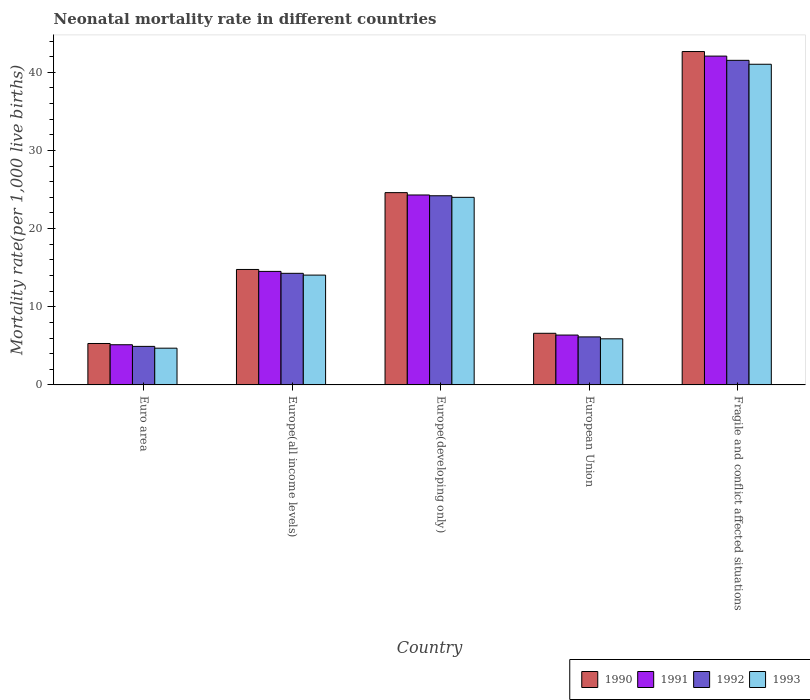How many groups of bars are there?
Keep it short and to the point. 5. Are the number of bars per tick equal to the number of legend labels?
Offer a very short reply. Yes. Are the number of bars on each tick of the X-axis equal?
Provide a short and direct response. Yes. How many bars are there on the 2nd tick from the right?
Your answer should be compact. 4. What is the label of the 5th group of bars from the left?
Ensure brevity in your answer.  Fragile and conflict affected situations. In how many cases, is the number of bars for a given country not equal to the number of legend labels?
Ensure brevity in your answer.  0. What is the neonatal mortality rate in 1993 in Europe(developing only)?
Make the answer very short. 24. Across all countries, what is the maximum neonatal mortality rate in 1990?
Your response must be concise. 42.65. Across all countries, what is the minimum neonatal mortality rate in 1990?
Your response must be concise. 5.3. In which country was the neonatal mortality rate in 1993 maximum?
Your response must be concise. Fragile and conflict affected situations. In which country was the neonatal mortality rate in 1992 minimum?
Ensure brevity in your answer.  Euro area. What is the total neonatal mortality rate in 1992 in the graph?
Keep it short and to the point. 91.07. What is the difference between the neonatal mortality rate in 1992 in European Union and that in Fragile and conflict affected situations?
Provide a succinct answer. -35.38. What is the difference between the neonatal mortality rate in 1991 in Fragile and conflict affected situations and the neonatal mortality rate in 1990 in European Union?
Provide a short and direct response. 35.46. What is the average neonatal mortality rate in 1993 per country?
Make the answer very short. 17.93. What is the difference between the neonatal mortality rate of/in 1992 and neonatal mortality rate of/in 1993 in Europe(all income levels)?
Your answer should be very brief. 0.23. What is the ratio of the neonatal mortality rate in 1990 in Europe(all income levels) to that in European Union?
Offer a very short reply. 2.24. Is the neonatal mortality rate in 1990 in Europe(all income levels) less than that in Fragile and conflict affected situations?
Your answer should be compact. Yes. What is the difference between the highest and the second highest neonatal mortality rate in 1993?
Offer a very short reply. -17.03. What is the difference between the highest and the lowest neonatal mortality rate in 1991?
Give a very brief answer. 36.93. Is the sum of the neonatal mortality rate in 1993 in Euro area and Europe(all income levels) greater than the maximum neonatal mortality rate in 1992 across all countries?
Your answer should be very brief. No. Is it the case that in every country, the sum of the neonatal mortality rate in 1991 and neonatal mortality rate in 1990 is greater than the sum of neonatal mortality rate in 1992 and neonatal mortality rate in 1993?
Offer a terse response. No. What does the 1st bar from the right in Euro area represents?
Your answer should be compact. 1993. Is it the case that in every country, the sum of the neonatal mortality rate in 1991 and neonatal mortality rate in 1992 is greater than the neonatal mortality rate in 1990?
Offer a very short reply. Yes. What is the difference between two consecutive major ticks on the Y-axis?
Ensure brevity in your answer.  10. Does the graph contain grids?
Provide a short and direct response. No. How are the legend labels stacked?
Your answer should be very brief. Horizontal. What is the title of the graph?
Provide a succinct answer. Neonatal mortality rate in different countries. What is the label or title of the X-axis?
Ensure brevity in your answer.  Country. What is the label or title of the Y-axis?
Give a very brief answer. Mortality rate(per 1,0 live births). What is the Mortality rate(per 1,000 live births) of 1990 in Euro area?
Your response must be concise. 5.3. What is the Mortality rate(per 1,000 live births) in 1991 in Euro area?
Offer a very short reply. 5.14. What is the Mortality rate(per 1,000 live births) of 1992 in Euro area?
Keep it short and to the point. 4.93. What is the Mortality rate(per 1,000 live births) of 1993 in Euro area?
Ensure brevity in your answer.  4.7. What is the Mortality rate(per 1,000 live births) in 1990 in Europe(all income levels)?
Give a very brief answer. 14.77. What is the Mortality rate(per 1,000 live births) in 1991 in Europe(all income levels)?
Offer a very short reply. 14.52. What is the Mortality rate(per 1,000 live births) in 1992 in Europe(all income levels)?
Provide a short and direct response. 14.28. What is the Mortality rate(per 1,000 live births) in 1993 in Europe(all income levels)?
Your answer should be very brief. 14.05. What is the Mortality rate(per 1,000 live births) of 1990 in Europe(developing only)?
Your response must be concise. 24.6. What is the Mortality rate(per 1,000 live births) of 1991 in Europe(developing only)?
Provide a short and direct response. 24.3. What is the Mortality rate(per 1,000 live births) of 1992 in Europe(developing only)?
Your answer should be very brief. 24.2. What is the Mortality rate(per 1,000 live births) of 1993 in Europe(developing only)?
Your answer should be very brief. 24. What is the Mortality rate(per 1,000 live births) of 1990 in European Union?
Make the answer very short. 6.6. What is the Mortality rate(per 1,000 live births) of 1991 in European Union?
Keep it short and to the point. 6.38. What is the Mortality rate(per 1,000 live births) in 1992 in European Union?
Make the answer very short. 6.14. What is the Mortality rate(per 1,000 live births) of 1993 in European Union?
Ensure brevity in your answer.  5.9. What is the Mortality rate(per 1,000 live births) in 1990 in Fragile and conflict affected situations?
Ensure brevity in your answer.  42.65. What is the Mortality rate(per 1,000 live births) in 1991 in Fragile and conflict affected situations?
Offer a terse response. 42.07. What is the Mortality rate(per 1,000 live births) in 1992 in Fragile and conflict affected situations?
Your answer should be very brief. 41.53. What is the Mortality rate(per 1,000 live births) of 1993 in Fragile and conflict affected situations?
Ensure brevity in your answer.  41.03. Across all countries, what is the maximum Mortality rate(per 1,000 live births) of 1990?
Your response must be concise. 42.65. Across all countries, what is the maximum Mortality rate(per 1,000 live births) in 1991?
Offer a very short reply. 42.07. Across all countries, what is the maximum Mortality rate(per 1,000 live births) of 1992?
Your answer should be very brief. 41.53. Across all countries, what is the maximum Mortality rate(per 1,000 live births) in 1993?
Provide a succinct answer. 41.03. Across all countries, what is the minimum Mortality rate(per 1,000 live births) of 1990?
Ensure brevity in your answer.  5.3. Across all countries, what is the minimum Mortality rate(per 1,000 live births) of 1991?
Keep it short and to the point. 5.14. Across all countries, what is the minimum Mortality rate(per 1,000 live births) of 1992?
Offer a very short reply. 4.93. Across all countries, what is the minimum Mortality rate(per 1,000 live births) of 1993?
Your answer should be very brief. 4.7. What is the total Mortality rate(per 1,000 live births) of 1990 in the graph?
Make the answer very short. 93.93. What is the total Mortality rate(per 1,000 live births) in 1991 in the graph?
Your answer should be very brief. 92.41. What is the total Mortality rate(per 1,000 live births) in 1992 in the graph?
Offer a terse response. 91.07. What is the total Mortality rate(per 1,000 live births) in 1993 in the graph?
Give a very brief answer. 89.67. What is the difference between the Mortality rate(per 1,000 live births) in 1990 in Euro area and that in Europe(all income levels)?
Your response must be concise. -9.47. What is the difference between the Mortality rate(per 1,000 live births) in 1991 in Euro area and that in Europe(all income levels)?
Provide a succinct answer. -9.38. What is the difference between the Mortality rate(per 1,000 live births) in 1992 in Euro area and that in Europe(all income levels)?
Your answer should be very brief. -9.35. What is the difference between the Mortality rate(per 1,000 live births) of 1993 in Euro area and that in Europe(all income levels)?
Your response must be concise. -9.35. What is the difference between the Mortality rate(per 1,000 live births) of 1990 in Euro area and that in Europe(developing only)?
Offer a terse response. -19.3. What is the difference between the Mortality rate(per 1,000 live births) in 1991 in Euro area and that in Europe(developing only)?
Your response must be concise. -19.16. What is the difference between the Mortality rate(per 1,000 live births) of 1992 in Euro area and that in Europe(developing only)?
Give a very brief answer. -19.27. What is the difference between the Mortality rate(per 1,000 live births) of 1993 in Euro area and that in Europe(developing only)?
Your answer should be very brief. -19.3. What is the difference between the Mortality rate(per 1,000 live births) of 1990 in Euro area and that in European Union?
Offer a very short reply. -1.3. What is the difference between the Mortality rate(per 1,000 live births) of 1991 in Euro area and that in European Union?
Your answer should be compact. -1.24. What is the difference between the Mortality rate(per 1,000 live births) of 1992 in Euro area and that in European Union?
Provide a succinct answer. -1.21. What is the difference between the Mortality rate(per 1,000 live births) of 1993 in Euro area and that in European Union?
Provide a short and direct response. -1.2. What is the difference between the Mortality rate(per 1,000 live births) of 1990 in Euro area and that in Fragile and conflict affected situations?
Your answer should be very brief. -37.35. What is the difference between the Mortality rate(per 1,000 live births) of 1991 in Euro area and that in Fragile and conflict affected situations?
Provide a succinct answer. -36.93. What is the difference between the Mortality rate(per 1,000 live births) in 1992 in Euro area and that in Fragile and conflict affected situations?
Provide a short and direct response. -36.6. What is the difference between the Mortality rate(per 1,000 live births) in 1993 in Euro area and that in Fragile and conflict affected situations?
Keep it short and to the point. -36.33. What is the difference between the Mortality rate(per 1,000 live births) of 1990 in Europe(all income levels) and that in Europe(developing only)?
Your answer should be very brief. -9.83. What is the difference between the Mortality rate(per 1,000 live births) in 1991 in Europe(all income levels) and that in Europe(developing only)?
Ensure brevity in your answer.  -9.78. What is the difference between the Mortality rate(per 1,000 live births) of 1992 in Europe(all income levels) and that in Europe(developing only)?
Offer a very short reply. -9.92. What is the difference between the Mortality rate(per 1,000 live births) of 1993 in Europe(all income levels) and that in Europe(developing only)?
Make the answer very short. -9.95. What is the difference between the Mortality rate(per 1,000 live births) in 1990 in Europe(all income levels) and that in European Union?
Ensure brevity in your answer.  8.17. What is the difference between the Mortality rate(per 1,000 live births) of 1991 in Europe(all income levels) and that in European Union?
Provide a succinct answer. 8.14. What is the difference between the Mortality rate(per 1,000 live births) of 1992 in Europe(all income levels) and that in European Union?
Provide a succinct answer. 8.14. What is the difference between the Mortality rate(per 1,000 live births) in 1993 in Europe(all income levels) and that in European Union?
Make the answer very short. 8.15. What is the difference between the Mortality rate(per 1,000 live births) in 1990 in Europe(all income levels) and that in Fragile and conflict affected situations?
Keep it short and to the point. -27.88. What is the difference between the Mortality rate(per 1,000 live births) of 1991 in Europe(all income levels) and that in Fragile and conflict affected situations?
Give a very brief answer. -27.55. What is the difference between the Mortality rate(per 1,000 live births) in 1992 in Europe(all income levels) and that in Fragile and conflict affected situations?
Your answer should be very brief. -27.25. What is the difference between the Mortality rate(per 1,000 live births) of 1993 in Europe(all income levels) and that in Fragile and conflict affected situations?
Make the answer very short. -26.98. What is the difference between the Mortality rate(per 1,000 live births) in 1990 in Europe(developing only) and that in European Union?
Make the answer very short. 18. What is the difference between the Mortality rate(per 1,000 live births) of 1991 in Europe(developing only) and that in European Union?
Offer a terse response. 17.92. What is the difference between the Mortality rate(per 1,000 live births) in 1992 in Europe(developing only) and that in European Union?
Provide a short and direct response. 18.06. What is the difference between the Mortality rate(per 1,000 live births) in 1993 in Europe(developing only) and that in European Union?
Your response must be concise. 18.1. What is the difference between the Mortality rate(per 1,000 live births) of 1990 in Europe(developing only) and that in Fragile and conflict affected situations?
Your response must be concise. -18.05. What is the difference between the Mortality rate(per 1,000 live births) in 1991 in Europe(developing only) and that in Fragile and conflict affected situations?
Ensure brevity in your answer.  -17.77. What is the difference between the Mortality rate(per 1,000 live births) of 1992 in Europe(developing only) and that in Fragile and conflict affected situations?
Offer a terse response. -17.33. What is the difference between the Mortality rate(per 1,000 live births) of 1993 in Europe(developing only) and that in Fragile and conflict affected situations?
Provide a short and direct response. -17.03. What is the difference between the Mortality rate(per 1,000 live births) in 1990 in European Union and that in Fragile and conflict affected situations?
Your response must be concise. -36.05. What is the difference between the Mortality rate(per 1,000 live births) of 1991 in European Union and that in Fragile and conflict affected situations?
Keep it short and to the point. -35.69. What is the difference between the Mortality rate(per 1,000 live births) in 1992 in European Union and that in Fragile and conflict affected situations?
Your answer should be compact. -35.38. What is the difference between the Mortality rate(per 1,000 live births) of 1993 in European Union and that in Fragile and conflict affected situations?
Ensure brevity in your answer.  -35.13. What is the difference between the Mortality rate(per 1,000 live births) of 1990 in Euro area and the Mortality rate(per 1,000 live births) of 1991 in Europe(all income levels)?
Your answer should be compact. -9.22. What is the difference between the Mortality rate(per 1,000 live births) of 1990 in Euro area and the Mortality rate(per 1,000 live births) of 1992 in Europe(all income levels)?
Your answer should be very brief. -8.98. What is the difference between the Mortality rate(per 1,000 live births) of 1990 in Euro area and the Mortality rate(per 1,000 live births) of 1993 in Europe(all income levels)?
Keep it short and to the point. -8.75. What is the difference between the Mortality rate(per 1,000 live births) in 1991 in Euro area and the Mortality rate(per 1,000 live births) in 1992 in Europe(all income levels)?
Offer a terse response. -9.14. What is the difference between the Mortality rate(per 1,000 live births) of 1991 in Euro area and the Mortality rate(per 1,000 live births) of 1993 in Europe(all income levels)?
Offer a very short reply. -8.91. What is the difference between the Mortality rate(per 1,000 live births) in 1992 in Euro area and the Mortality rate(per 1,000 live births) in 1993 in Europe(all income levels)?
Your answer should be compact. -9.12. What is the difference between the Mortality rate(per 1,000 live births) in 1990 in Euro area and the Mortality rate(per 1,000 live births) in 1991 in Europe(developing only)?
Your answer should be very brief. -19. What is the difference between the Mortality rate(per 1,000 live births) of 1990 in Euro area and the Mortality rate(per 1,000 live births) of 1992 in Europe(developing only)?
Provide a succinct answer. -18.9. What is the difference between the Mortality rate(per 1,000 live births) of 1990 in Euro area and the Mortality rate(per 1,000 live births) of 1993 in Europe(developing only)?
Provide a short and direct response. -18.7. What is the difference between the Mortality rate(per 1,000 live births) of 1991 in Euro area and the Mortality rate(per 1,000 live births) of 1992 in Europe(developing only)?
Provide a short and direct response. -19.06. What is the difference between the Mortality rate(per 1,000 live births) of 1991 in Euro area and the Mortality rate(per 1,000 live births) of 1993 in Europe(developing only)?
Your response must be concise. -18.86. What is the difference between the Mortality rate(per 1,000 live births) in 1992 in Euro area and the Mortality rate(per 1,000 live births) in 1993 in Europe(developing only)?
Keep it short and to the point. -19.07. What is the difference between the Mortality rate(per 1,000 live births) of 1990 in Euro area and the Mortality rate(per 1,000 live births) of 1991 in European Union?
Keep it short and to the point. -1.08. What is the difference between the Mortality rate(per 1,000 live births) of 1990 in Euro area and the Mortality rate(per 1,000 live births) of 1992 in European Union?
Offer a very short reply. -0.84. What is the difference between the Mortality rate(per 1,000 live births) in 1990 in Euro area and the Mortality rate(per 1,000 live births) in 1993 in European Union?
Give a very brief answer. -0.6. What is the difference between the Mortality rate(per 1,000 live births) of 1991 in Euro area and the Mortality rate(per 1,000 live births) of 1992 in European Union?
Make the answer very short. -1. What is the difference between the Mortality rate(per 1,000 live births) of 1991 in Euro area and the Mortality rate(per 1,000 live births) of 1993 in European Union?
Provide a short and direct response. -0.76. What is the difference between the Mortality rate(per 1,000 live births) in 1992 in Euro area and the Mortality rate(per 1,000 live births) in 1993 in European Union?
Offer a terse response. -0.97. What is the difference between the Mortality rate(per 1,000 live births) in 1990 in Euro area and the Mortality rate(per 1,000 live births) in 1991 in Fragile and conflict affected situations?
Provide a short and direct response. -36.77. What is the difference between the Mortality rate(per 1,000 live births) of 1990 in Euro area and the Mortality rate(per 1,000 live births) of 1992 in Fragile and conflict affected situations?
Make the answer very short. -36.23. What is the difference between the Mortality rate(per 1,000 live births) in 1990 in Euro area and the Mortality rate(per 1,000 live births) in 1993 in Fragile and conflict affected situations?
Provide a succinct answer. -35.73. What is the difference between the Mortality rate(per 1,000 live births) in 1991 in Euro area and the Mortality rate(per 1,000 live births) in 1992 in Fragile and conflict affected situations?
Your response must be concise. -36.39. What is the difference between the Mortality rate(per 1,000 live births) in 1991 in Euro area and the Mortality rate(per 1,000 live births) in 1993 in Fragile and conflict affected situations?
Give a very brief answer. -35.89. What is the difference between the Mortality rate(per 1,000 live births) of 1992 in Euro area and the Mortality rate(per 1,000 live births) of 1993 in Fragile and conflict affected situations?
Ensure brevity in your answer.  -36.1. What is the difference between the Mortality rate(per 1,000 live births) in 1990 in Europe(all income levels) and the Mortality rate(per 1,000 live births) in 1991 in Europe(developing only)?
Offer a very short reply. -9.53. What is the difference between the Mortality rate(per 1,000 live births) in 1990 in Europe(all income levels) and the Mortality rate(per 1,000 live births) in 1992 in Europe(developing only)?
Provide a succinct answer. -9.43. What is the difference between the Mortality rate(per 1,000 live births) in 1990 in Europe(all income levels) and the Mortality rate(per 1,000 live births) in 1993 in Europe(developing only)?
Give a very brief answer. -9.23. What is the difference between the Mortality rate(per 1,000 live births) of 1991 in Europe(all income levels) and the Mortality rate(per 1,000 live births) of 1992 in Europe(developing only)?
Your response must be concise. -9.68. What is the difference between the Mortality rate(per 1,000 live births) of 1991 in Europe(all income levels) and the Mortality rate(per 1,000 live births) of 1993 in Europe(developing only)?
Provide a succinct answer. -9.48. What is the difference between the Mortality rate(per 1,000 live births) of 1992 in Europe(all income levels) and the Mortality rate(per 1,000 live births) of 1993 in Europe(developing only)?
Make the answer very short. -9.72. What is the difference between the Mortality rate(per 1,000 live births) of 1990 in Europe(all income levels) and the Mortality rate(per 1,000 live births) of 1991 in European Union?
Your answer should be very brief. 8.39. What is the difference between the Mortality rate(per 1,000 live births) in 1990 in Europe(all income levels) and the Mortality rate(per 1,000 live births) in 1992 in European Union?
Give a very brief answer. 8.63. What is the difference between the Mortality rate(per 1,000 live births) of 1990 in Europe(all income levels) and the Mortality rate(per 1,000 live births) of 1993 in European Union?
Provide a succinct answer. 8.87. What is the difference between the Mortality rate(per 1,000 live births) in 1991 in Europe(all income levels) and the Mortality rate(per 1,000 live births) in 1992 in European Union?
Your answer should be very brief. 8.38. What is the difference between the Mortality rate(per 1,000 live births) in 1991 in Europe(all income levels) and the Mortality rate(per 1,000 live births) in 1993 in European Union?
Your answer should be very brief. 8.63. What is the difference between the Mortality rate(per 1,000 live births) of 1992 in Europe(all income levels) and the Mortality rate(per 1,000 live births) of 1993 in European Union?
Your response must be concise. 8.38. What is the difference between the Mortality rate(per 1,000 live births) in 1990 in Europe(all income levels) and the Mortality rate(per 1,000 live births) in 1991 in Fragile and conflict affected situations?
Offer a terse response. -27.3. What is the difference between the Mortality rate(per 1,000 live births) of 1990 in Europe(all income levels) and the Mortality rate(per 1,000 live births) of 1992 in Fragile and conflict affected situations?
Keep it short and to the point. -26.76. What is the difference between the Mortality rate(per 1,000 live births) of 1990 in Europe(all income levels) and the Mortality rate(per 1,000 live births) of 1993 in Fragile and conflict affected situations?
Your answer should be very brief. -26.25. What is the difference between the Mortality rate(per 1,000 live births) in 1991 in Europe(all income levels) and the Mortality rate(per 1,000 live births) in 1992 in Fragile and conflict affected situations?
Your answer should be very brief. -27. What is the difference between the Mortality rate(per 1,000 live births) of 1991 in Europe(all income levels) and the Mortality rate(per 1,000 live births) of 1993 in Fragile and conflict affected situations?
Your answer should be compact. -26.5. What is the difference between the Mortality rate(per 1,000 live births) in 1992 in Europe(all income levels) and the Mortality rate(per 1,000 live births) in 1993 in Fragile and conflict affected situations?
Provide a succinct answer. -26.75. What is the difference between the Mortality rate(per 1,000 live births) in 1990 in Europe(developing only) and the Mortality rate(per 1,000 live births) in 1991 in European Union?
Your response must be concise. 18.22. What is the difference between the Mortality rate(per 1,000 live births) in 1990 in Europe(developing only) and the Mortality rate(per 1,000 live births) in 1992 in European Union?
Give a very brief answer. 18.46. What is the difference between the Mortality rate(per 1,000 live births) in 1990 in Europe(developing only) and the Mortality rate(per 1,000 live births) in 1993 in European Union?
Offer a very short reply. 18.7. What is the difference between the Mortality rate(per 1,000 live births) of 1991 in Europe(developing only) and the Mortality rate(per 1,000 live births) of 1992 in European Union?
Give a very brief answer. 18.16. What is the difference between the Mortality rate(per 1,000 live births) in 1991 in Europe(developing only) and the Mortality rate(per 1,000 live births) in 1993 in European Union?
Provide a short and direct response. 18.4. What is the difference between the Mortality rate(per 1,000 live births) in 1992 in Europe(developing only) and the Mortality rate(per 1,000 live births) in 1993 in European Union?
Provide a succinct answer. 18.3. What is the difference between the Mortality rate(per 1,000 live births) of 1990 in Europe(developing only) and the Mortality rate(per 1,000 live births) of 1991 in Fragile and conflict affected situations?
Your answer should be very brief. -17.47. What is the difference between the Mortality rate(per 1,000 live births) in 1990 in Europe(developing only) and the Mortality rate(per 1,000 live births) in 1992 in Fragile and conflict affected situations?
Make the answer very short. -16.93. What is the difference between the Mortality rate(per 1,000 live births) in 1990 in Europe(developing only) and the Mortality rate(per 1,000 live births) in 1993 in Fragile and conflict affected situations?
Provide a succinct answer. -16.43. What is the difference between the Mortality rate(per 1,000 live births) of 1991 in Europe(developing only) and the Mortality rate(per 1,000 live births) of 1992 in Fragile and conflict affected situations?
Your response must be concise. -17.23. What is the difference between the Mortality rate(per 1,000 live births) of 1991 in Europe(developing only) and the Mortality rate(per 1,000 live births) of 1993 in Fragile and conflict affected situations?
Offer a terse response. -16.73. What is the difference between the Mortality rate(per 1,000 live births) in 1992 in Europe(developing only) and the Mortality rate(per 1,000 live births) in 1993 in Fragile and conflict affected situations?
Keep it short and to the point. -16.83. What is the difference between the Mortality rate(per 1,000 live births) of 1990 in European Union and the Mortality rate(per 1,000 live births) of 1991 in Fragile and conflict affected situations?
Give a very brief answer. -35.46. What is the difference between the Mortality rate(per 1,000 live births) of 1990 in European Union and the Mortality rate(per 1,000 live births) of 1992 in Fragile and conflict affected situations?
Your answer should be very brief. -34.92. What is the difference between the Mortality rate(per 1,000 live births) in 1990 in European Union and the Mortality rate(per 1,000 live births) in 1993 in Fragile and conflict affected situations?
Make the answer very short. -34.42. What is the difference between the Mortality rate(per 1,000 live births) in 1991 in European Union and the Mortality rate(per 1,000 live births) in 1992 in Fragile and conflict affected situations?
Offer a very short reply. -35.15. What is the difference between the Mortality rate(per 1,000 live births) in 1991 in European Union and the Mortality rate(per 1,000 live births) in 1993 in Fragile and conflict affected situations?
Your answer should be compact. -34.65. What is the difference between the Mortality rate(per 1,000 live births) of 1992 in European Union and the Mortality rate(per 1,000 live births) of 1993 in Fragile and conflict affected situations?
Your answer should be very brief. -34.88. What is the average Mortality rate(per 1,000 live births) of 1990 per country?
Ensure brevity in your answer.  18.79. What is the average Mortality rate(per 1,000 live births) in 1991 per country?
Provide a succinct answer. 18.48. What is the average Mortality rate(per 1,000 live births) in 1992 per country?
Your answer should be very brief. 18.21. What is the average Mortality rate(per 1,000 live births) in 1993 per country?
Ensure brevity in your answer.  17.93. What is the difference between the Mortality rate(per 1,000 live births) of 1990 and Mortality rate(per 1,000 live births) of 1991 in Euro area?
Keep it short and to the point. 0.16. What is the difference between the Mortality rate(per 1,000 live births) in 1990 and Mortality rate(per 1,000 live births) in 1992 in Euro area?
Keep it short and to the point. 0.37. What is the difference between the Mortality rate(per 1,000 live births) in 1990 and Mortality rate(per 1,000 live births) in 1993 in Euro area?
Give a very brief answer. 0.6. What is the difference between the Mortality rate(per 1,000 live births) in 1991 and Mortality rate(per 1,000 live births) in 1992 in Euro area?
Your response must be concise. 0.21. What is the difference between the Mortality rate(per 1,000 live births) in 1991 and Mortality rate(per 1,000 live births) in 1993 in Euro area?
Ensure brevity in your answer.  0.44. What is the difference between the Mortality rate(per 1,000 live births) in 1992 and Mortality rate(per 1,000 live births) in 1993 in Euro area?
Your answer should be very brief. 0.23. What is the difference between the Mortality rate(per 1,000 live births) of 1990 and Mortality rate(per 1,000 live births) of 1991 in Europe(all income levels)?
Give a very brief answer. 0.25. What is the difference between the Mortality rate(per 1,000 live births) in 1990 and Mortality rate(per 1,000 live births) in 1992 in Europe(all income levels)?
Your response must be concise. 0.49. What is the difference between the Mortality rate(per 1,000 live births) in 1990 and Mortality rate(per 1,000 live births) in 1993 in Europe(all income levels)?
Offer a terse response. 0.72. What is the difference between the Mortality rate(per 1,000 live births) of 1991 and Mortality rate(per 1,000 live births) of 1992 in Europe(all income levels)?
Ensure brevity in your answer.  0.25. What is the difference between the Mortality rate(per 1,000 live births) of 1991 and Mortality rate(per 1,000 live births) of 1993 in Europe(all income levels)?
Provide a short and direct response. 0.47. What is the difference between the Mortality rate(per 1,000 live births) in 1992 and Mortality rate(per 1,000 live births) in 1993 in Europe(all income levels)?
Give a very brief answer. 0.23. What is the difference between the Mortality rate(per 1,000 live births) in 1990 and Mortality rate(per 1,000 live births) in 1991 in Europe(developing only)?
Offer a very short reply. 0.3. What is the difference between the Mortality rate(per 1,000 live births) of 1990 and Mortality rate(per 1,000 live births) of 1992 in Europe(developing only)?
Your answer should be compact. 0.4. What is the difference between the Mortality rate(per 1,000 live births) of 1990 and Mortality rate(per 1,000 live births) of 1993 in Europe(developing only)?
Ensure brevity in your answer.  0.6. What is the difference between the Mortality rate(per 1,000 live births) in 1991 and Mortality rate(per 1,000 live births) in 1992 in Europe(developing only)?
Ensure brevity in your answer.  0.1. What is the difference between the Mortality rate(per 1,000 live births) in 1992 and Mortality rate(per 1,000 live births) in 1993 in Europe(developing only)?
Your response must be concise. 0.2. What is the difference between the Mortality rate(per 1,000 live births) in 1990 and Mortality rate(per 1,000 live births) in 1991 in European Union?
Your answer should be very brief. 0.23. What is the difference between the Mortality rate(per 1,000 live births) of 1990 and Mortality rate(per 1,000 live births) of 1992 in European Union?
Provide a succinct answer. 0.46. What is the difference between the Mortality rate(per 1,000 live births) in 1990 and Mortality rate(per 1,000 live births) in 1993 in European Union?
Your answer should be compact. 0.71. What is the difference between the Mortality rate(per 1,000 live births) in 1991 and Mortality rate(per 1,000 live births) in 1992 in European Union?
Ensure brevity in your answer.  0.24. What is the difference between the Mortality rate(per 1,000 live births) in 1991 and Mortality rate(per 1,000 live births) in 1993 in European Union?
Your response must be concise. 0.48. What is the difference between the Mortality rate(per 1,000 live births) of 1992 and Mortality rate(per 1,000 live births) of 1993 in European Union?
Offer a very short reply. 0.24. What is the difference between the Mortality rate(per 1,000 live births) of 1990 and Mortality rate(per 1,000 live births) of 1991 in Fragile and conflict affected situations?
Offer a very short reply. 0.58. What is the difference between the Mortality rate(per 1,000 live births) in 1990 and Mortality rate(per 1,000 live births) in 1992 in Fragile and conflict affected situations?
Keep it short and to the point. 1.13. What is the difference between the Mortality rate(per 1,000 live births) in 1990 and Mortality rate(per 1,000 live births) in 1993 in Fragile and conflict affected situations?
Your answer should be compact. 1.63. What is the difference between the Mortality rate(per 1,000 live births) in 1991 and Mortality rate(per 1,000 live births) in 1992 in Fragile and conflict affected situations?
Ensure brevity in your answer.  0.54. What is the difference between the Mortality rate(per 1,000 live births) of 1991 and Mortality rate(per 1,000 live births) of 1993 in Fragile and conflict affected situations?
Make the answer very short. 1.04. What is the difference between the Mortality rate(per 1,000 live births) of 1992 and Mortality rate(per 1,000 live births) of 1993 in Fragile and conflict affected situations?
Give a very brief answer. 0.5. What is the ratio of the Mortality rate(per 1,000 live births) of 1990 in Euro area to that in Europe(all income levels)?
Your response must be concise. 0.36. What is the ratio of the Mortality rate(per 1,000 live births) of 1991 in Euro area to that in Europe(all income levels)?
Ensure brevity in your answer.  0.35. What is the ratio of the Mortality rate(per 1,000 live births) in 1992 in Euro area to that in Europe(all income levels)?
Make the answer very short. 0.35. What is the ratio of the Mortality rate(per 1,000 live births) in 1993 in Euro area to that in Europe(all income levels)?
Your answer should be very brief. 0.33. What is the ratio of the Mortality rate(per 1,000 live births) in 1990 in Euro area to that in Europe(developing only)?
Your answer should be compact. 0.22. What is the ratio of the Mortality rate(per 1,000 live births) of 1991 in Euro area to that in Europe(developing only)?
Keep it short and to the point. 0.21. What is the ratio of the Mortality rate(per 1,000 live births) of 1992 in Euro area to that in Europe(developing only)?
Ensure brevity in your answer.  0.2. What is the ratio of the Mortality rate(per 1,000 live births) of 1993 in Euro area to that in Europe(developing only)?
Your response must be concise. 0.2. What is the ratio of the Mortality rate(per 1,000 live births) of 1990 in Euro area to that in European Union?
Your answer should be compact. 0.8. What is the ratio of the Mortality rate(per 1,000 live births) in 1991 in Euro area to that in European Union?
Your response must be concise. 0.81. What is the ratio of the Mortality rate(per 1,000 live births) in 1992 in Euro area to that in European Union?
Make the answer very short. 0.8. What is the ratio of the Mortality rate(per 1,000 live births) in 1993 in Euro area to that in European Union?
Provide a succinct answer. 0.8. What is the ratio of the Mortality rate(per 1,000 live births) of 1990 in Euro area to that in Fragile and conflict affected situations?
Give a very brief answer. 0.12. What is the ratio of the Mortality rate(per 1,000 live births) of 1991 in Euro area to that in Fragile and conflict affected situations?
Give a very brief answer. 0.12. What is the ratio of the Mortality rate(per 1,000 live births) of 1992 in Euro area to that in Fragile and conflict affected situations?
Offer a terse response. 0.12. What is the ratio of the Mortality rate(per 1,000 live births) of 1993 in Euro area to that in Fragile and conflict affected situations?
Provide a short and direct response. 0.11. What is the ratio of the Mortality rate(per 1,000 live births) in 1990 in Europe(all income levels) to that in Europe(developing only)?
Your answer should be compact. 0.6. What is the ratio of the Mortality rate(per 1,000 live births) of 1991 in Europe(all income levels) to that in Europe(developing only)?
Make the answer very short. 0.6. What is the ratio of the Mortality rate(per 1,000 live births) in 1992 in Europe(all income levels) to that in Europe(developing only)?
Offer a very short reply. 0.59. What is the ratio of the Mortality rate(per 1,000 live births) of 1993 in Europe(all income levels) to that in Europe(developing only)?
Offer a very short reply. 0.59. What is the ratio of the Mortality rate(per 1,000 live births) of 1990 in Europe(all income levels) to that in European Union?
Provide a succinct answer. 2.24. What is the ratio of the Mortality rate(per 1,000 live births) of 1991 in Europe(all income levels) to that in European Union?
Offer a very short reply. 2.28. What is the ratio of the Mortality rate(per 1,000 live births) in 1992 in Europe(all income levels) to that in European Union?
Your answer should be compact. 2.32. What is the ratio of the Mortality rate(per 1,000 live births) of 1993 in Europe(all income levels) to that in European Union?
Your response must be concise. 2.38. What is the ratio of the Mortality rate(per 1,000 live births) of 1990 in Europe(all income levels) to that in Fragile and conflict affected situations?
Your answer should be very brief. 0.35. What is the ratio of the Mortality rate(per 1,000 live births) in 1991 in Europe(all income levels) to that in Fragile and conflict affected situations?
Keep it short and to the point. 0.35. What is the ratio of the Mortality rate(per 1,000 live births) of 1992 in Europe(all income levels) to that in Fragile and conflict affected situations?
Provide a succinct answer. 0.34. What is the ratio of the Mortality rate(per 1,000 live births) in 1993 in Europe(all income levels) to that in Fragile and conflict affected situations?
Ensure brevity in your answer.  0.34. What is the ratio of the Mortality rate(per 1,000 live births) in 1990 in Europe(developing only) to that in European Union?
Make the answer very short. 3.72. What is the ratio of the Mortality rate(per 1,000 live births) in 1991 in Europe(developing only) to that in European Union?
Ensure brevity in your answer.  3.81. What is the ratio of the Mortality rate(per 1,000 live births) in 1992 in Europe(developing only) to that in European Union?
Your answer should be compact. 3.94. What is the ratio of the Mortality rate(per 1,000 live births) in 1993 in Europe(developing only) to that in European Union?
Offer a terse response. 4.07. What is the ratio of the Mortality rate(per 1,000 live births) of 1990 in Europe(developing only) to that in Fragile and conflict affected situations?
Make the answer very short. 0.58. What is the ratio of the Mortality rate(per 1,000 live births) of 1991 in Europe(developing only) to that in Fragile and conflict affected situations?
Ensure brevity in your answer.  0.58. What is the ratio of the Mortality rate(per 1,000 live births) in 1992 in Europe(developing only) to that in Fragile and conflict affected situations?
Provide a succinct answer. 0.58. What is the ratio of the Mortality rate(per 1,000 live births) in 1993 in Europe(developing only) to that in Fragile and conflict affected situations?
Ensure brevity in your answer.  0.58. What is the ratio of the Mortality rate(per 1,000 live births) in 1990 in European Union to that in Fragile and conflict affected situations?
Give a very brief answer. 0.15. What is the ratio of the Mortality rate(per 1,000 live births) of 1991 in European Union to that in Fragile and conflict affected situations?
Keep it short and to the point. 0.15. What is the ratio of the Mortality rate(per 1,000 live births) in 1992 in European Union to that in Fragile and conflict affected situations?
Offer a very short reply. 0.15. What is the ratio of the Mortality rate(per 1,000 live births) in 1993 in European Union to that in Fragile and conflict affected situations?
Keep it short and to the point. 0.14. What is the difference between the highest and the second highest Mortality rate(per 1,000 live births) of 1990?
Your answer should be compact. 18.05. What is the difference between the highest and the second highest Mortality rate(per 1,000 live births) in 1991?
Your answer should be very brief. 17.77. What is the difference between the highest and the second highest Mortality rate(per 1,000 live births) in 1992?
Your response must be concise. 17.33. What is the difference between the highest and the second highest Mortality rate(per 1,000 live births) in 1993?
Give a very brief answer. 17.03. What is the difference between the highest and the lowest Mortality rate(per 1,000 live births) of 1990?
Make the answer very short. 37.35. What is the difference between the highest and the lowest Mortality rate(per 1,000 live births) of 1991?
Your answer should be compact. 36.93. What is the difference between the highest and the lowest Mortality rate(per 1,000 live births) of 1992?
Provide a succinct answer. 36.6. What is the difference between the highest and the lowest Mortality rate(per 1,000 live births) of 1993?
Your answer should be very brief. 36.33. 